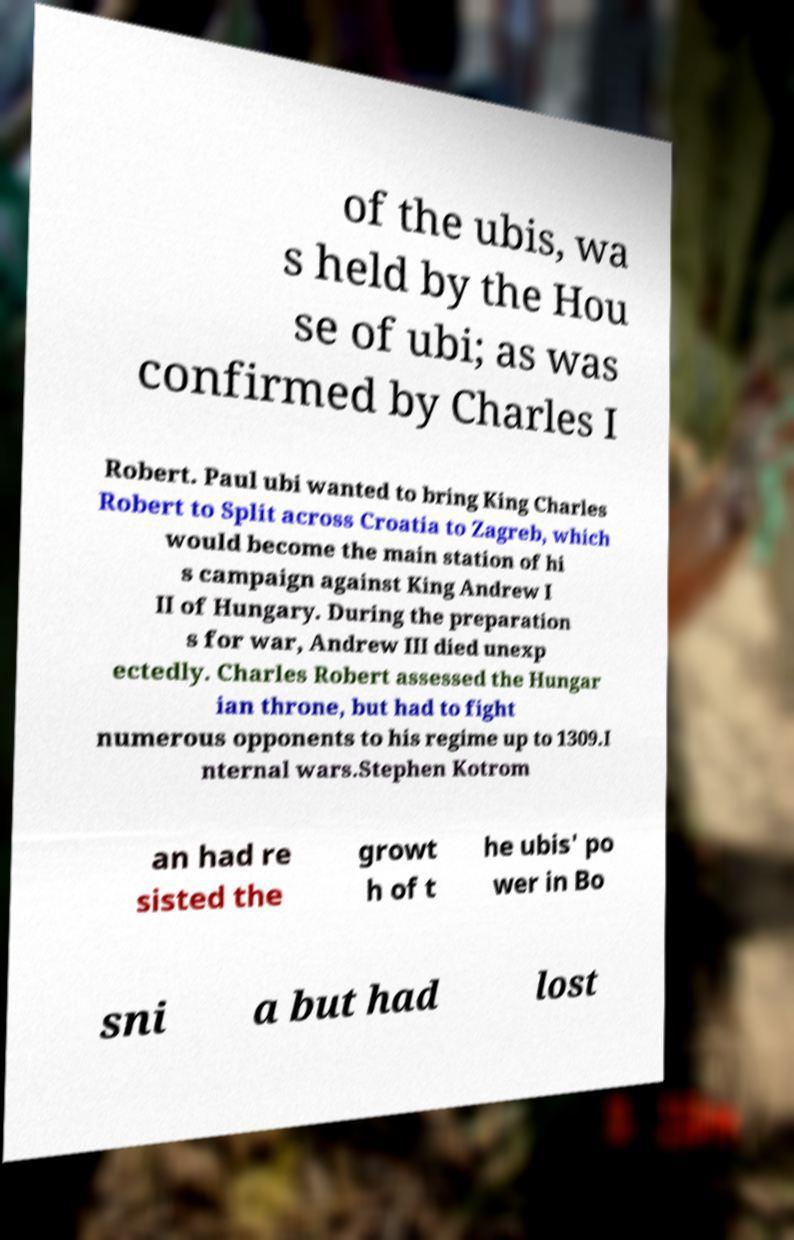Could you assist in decoding the text presented in this image and type it out clearly? of the ubis, wa s held by the Hou se of ubi; as was confirmed by Charles I Robert. Paul ubi wanted to bring King Charles Robert to Split across Croatia to Zagreb, which would become the main station of hi s campaign against King Andrew I II of Hungary. During the preparation s for war, Andrew III died unexp ectedly. Charles Robert assessed the Hungar ian throne, but had to fight numerous opponents to his regime up to 1309.I nternal wars.Stephen Kotrom an had re sisted the growt h of t he ubis' po wer in Bo sni a but had lost 